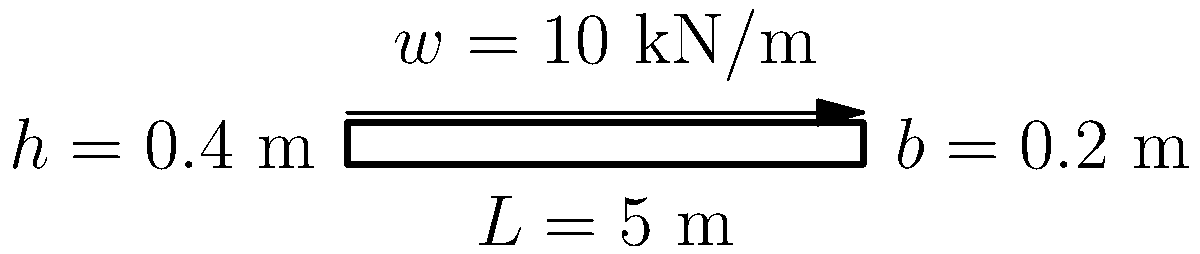As a budget-conscious student looking for affordable housing options in Boston, you come across a potential fixer-upper. The living room has an exposed wooden beam that you want to assess for safety. Given a simply supported wooden beam with a length of 5 m, width of 0.2 m, and height of 0.4 m, subjected to a uniformly distributed load of 10 kN/m, calculate the maximum bending stress in the beam. Assume the modulus of elasticity (E) for the wood is 11 GPa and the allowable bending stress is 10 MPa. Is this beam safe for use? Let's approach this step-by-step:

1) First, calculate the moment of inertia (I) of the beam:
   $$I = \frac{bh^3}{12} = \frac{0.2 \times 0.4^3}{12} = 1.0667 \times 10^{-3} \text{ m}^4$$

2) Calculate the maximum bending moment (M) at the center of the beam:
   $$M = \frac{wL^2}{8} = \frac{10 \times 5^2}{8} = 31.25 \text{ kN}\cdot\text{m}$$

3) Calculate the section modulus (S):
   $$S = \frac{bh^2}{6} = \frac{0.2 \times 0.4^2}{6} = 5.333 \times 10^{-3} \text{ m}^3$$

4) Calculate the maximum bending stress (σ):
   $$\sigma = \frac{M}{S} = \frac{31.25}{5.333 \times 10^{-3}} = 5.86 \text{ MPa}$$

5) Compare the maximum bending stress to the allowable bending stress:
   5.86 MPa < 10 MPa (allowable)

Therefore, the beam is safe for use as the maximum bending stress (5.86 MPa) is less than the allowable bending stress (10 MPa).
Answer: 5.86 MPa; Safe 